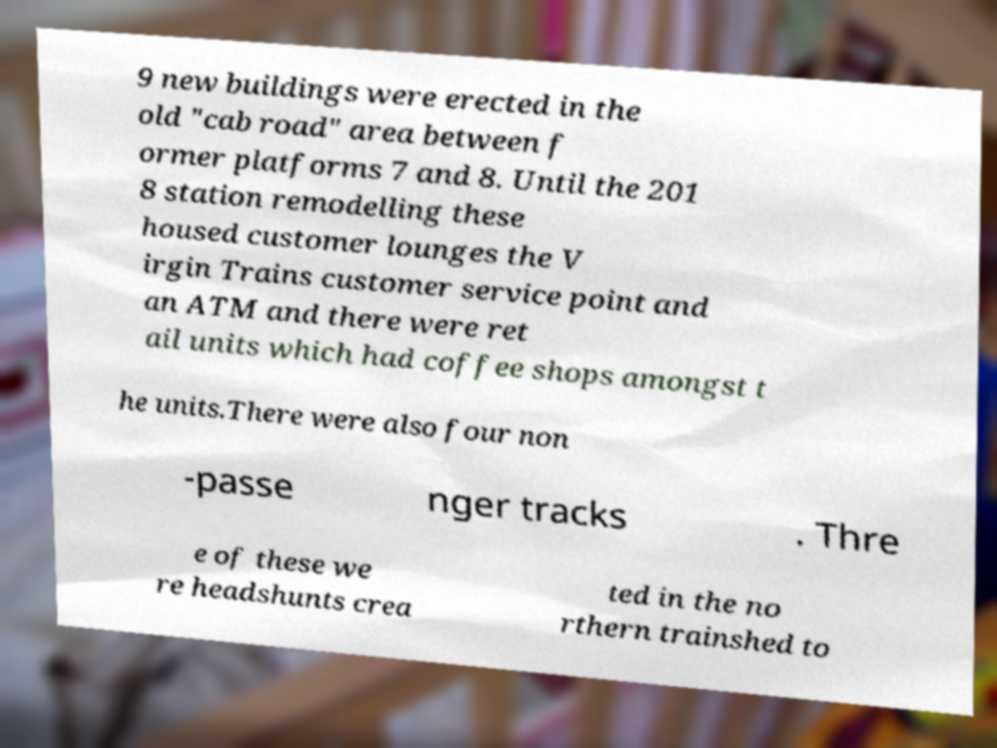For documentation purposes, I need the text within this image transcribed. Could you provide that? 9 new buildings were erected in the old "cab road" area between f ormer platforms 7 and 8. Until the 201 8 station remodelling these housed customer lounges the V irgin Trains customer service point and an ATM and there were ret ail units which had coffee shops amongst t he units.There were also four non -passe nger tracks . Thre e of these we re headshunts crea ted in the no rthern trainshed to 